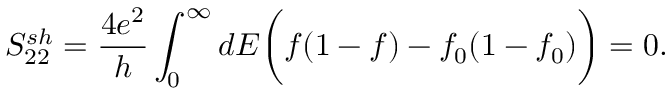<formula> <loc_0><loc_0><loc_500><loc_500>{ S _ { 2 2 } ^ { s h } = \frac { 4 e ^ { 2 } } { h } \int _ { 0 } ^ { \infty } d E \left ( f ( 1 - f ) - f _ { 0 } ( 1 - f _ { 0 } ) \right ) = 0 . }</formula> 